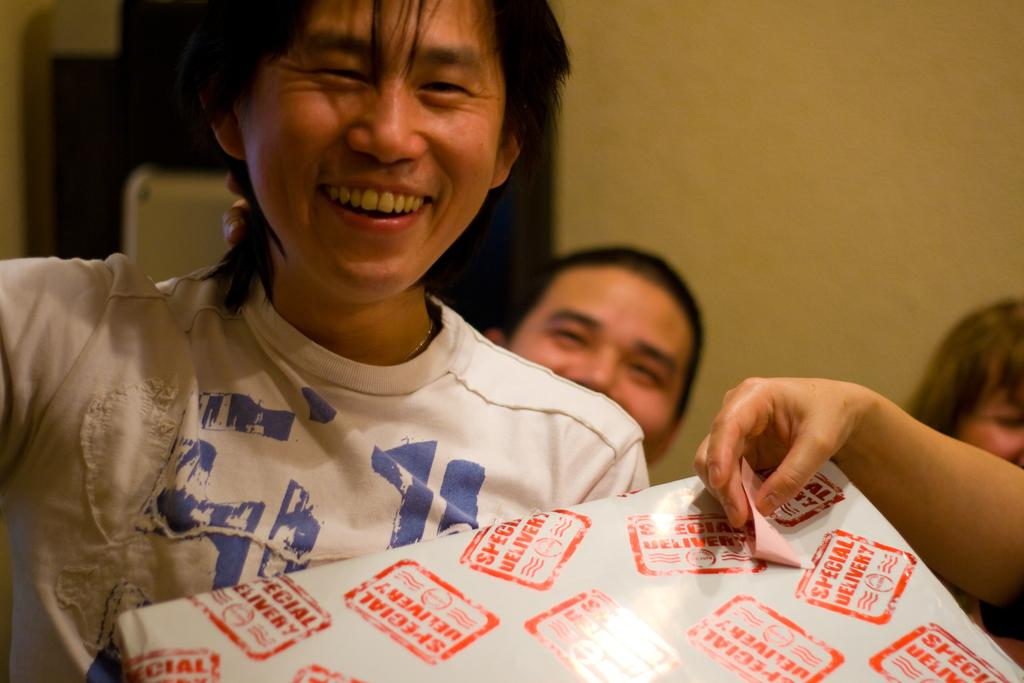How many people are the people are in the image? There is a group of people in the image. Can you describe the clothing of one of the individuals? One person is wearing a white color shirt. What is the color of the object in the image? There is an object in white color in the image. What is the color of the background in the image? The background of the image is in cream color. What type of caption is written on the feather in the image? There is no feather or caption present in the image. Can you describe the pencil used by one of the people in the image? There is no pencil visible in the image. 